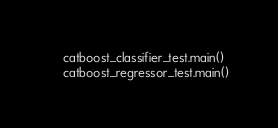<code> <loc_0><loc_0><loc_500><loc_500><_Python_>    catboost_classifier_test.main()
    catboost_regressor_test.main()

</code> 